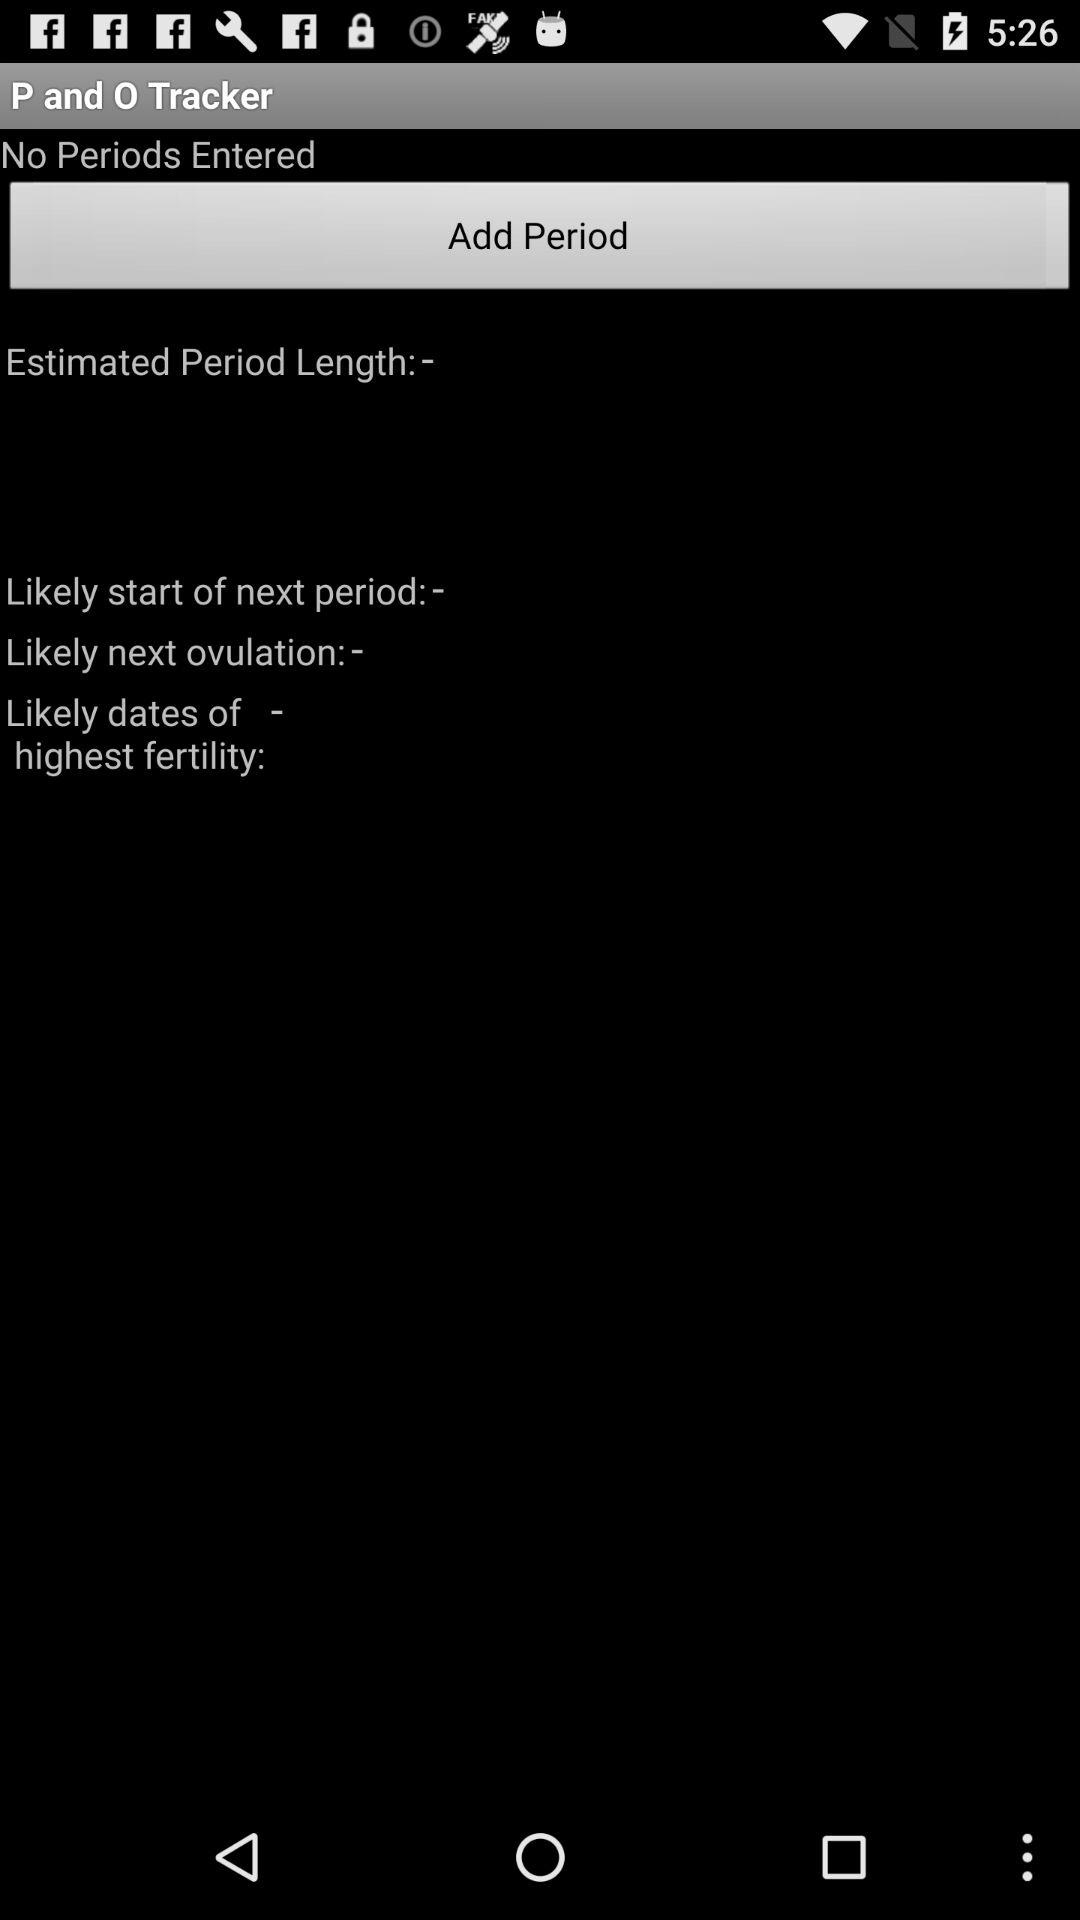What is the tracker name? The tracker name is "P and O". 